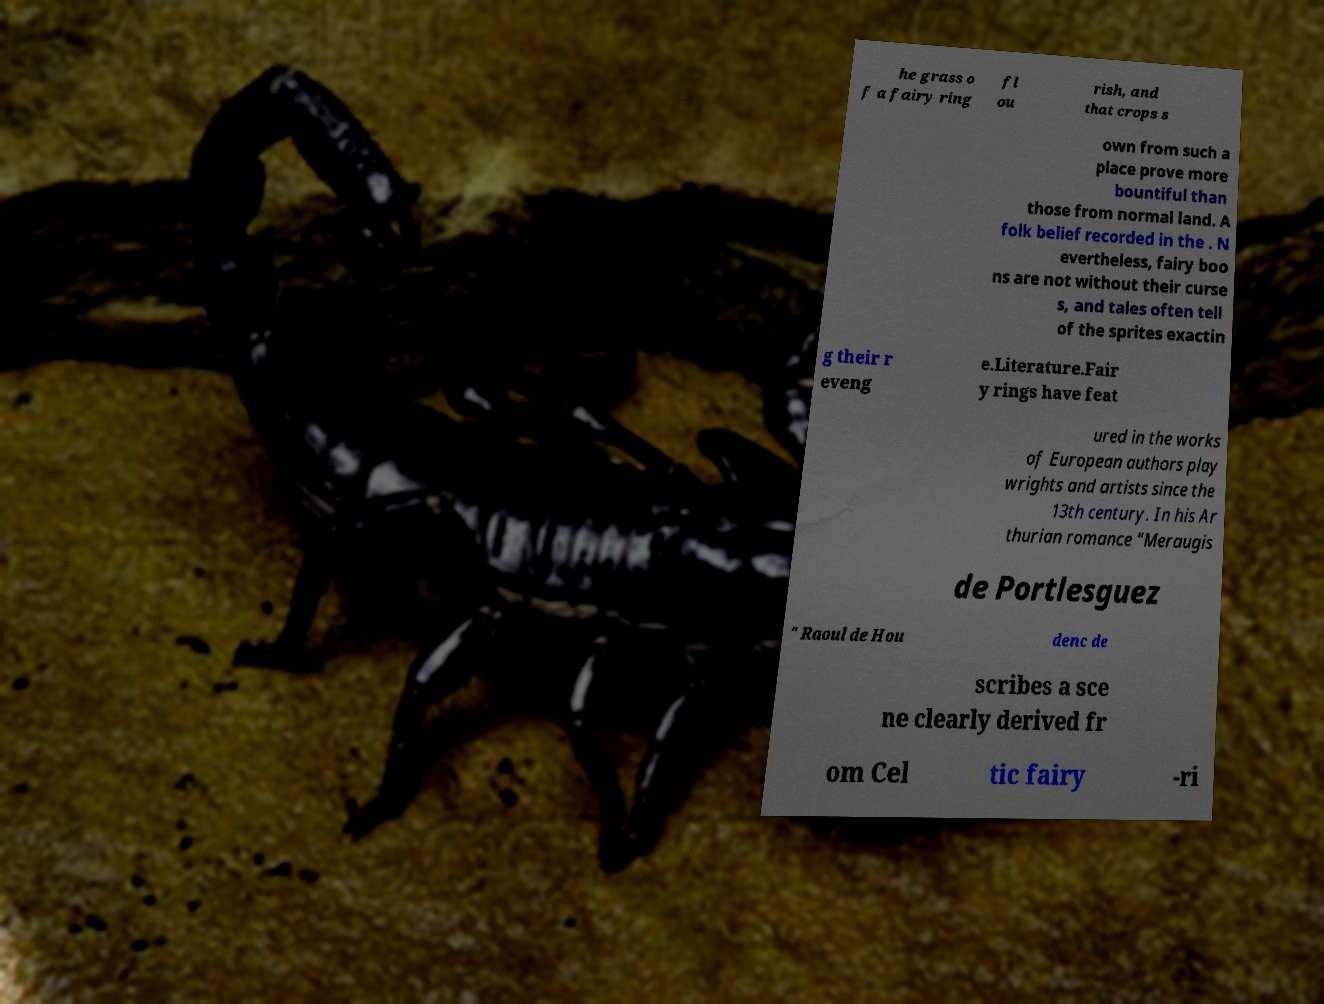There's text embedded in this image that I need extracted. Can you transcribe it verbatim? he grass o f a fairy ring fl ou rish, and that crops s own from such a place prove more bountiful than those from normal land. A folk belief recorded in the . N evertheless, fairy boo ns are not without their curse s, and tales often tell of the sprites exactin g their r eveng e.Literature.Fair y rings have feat ured in the works of European authors play wrights and artists since the 13th century. In his Ar thurian romance "Meraugis de Portlesguez " Raoul de Hou denc de scribes a sce ne clearly derived fr om Cel tic fairy -ri 